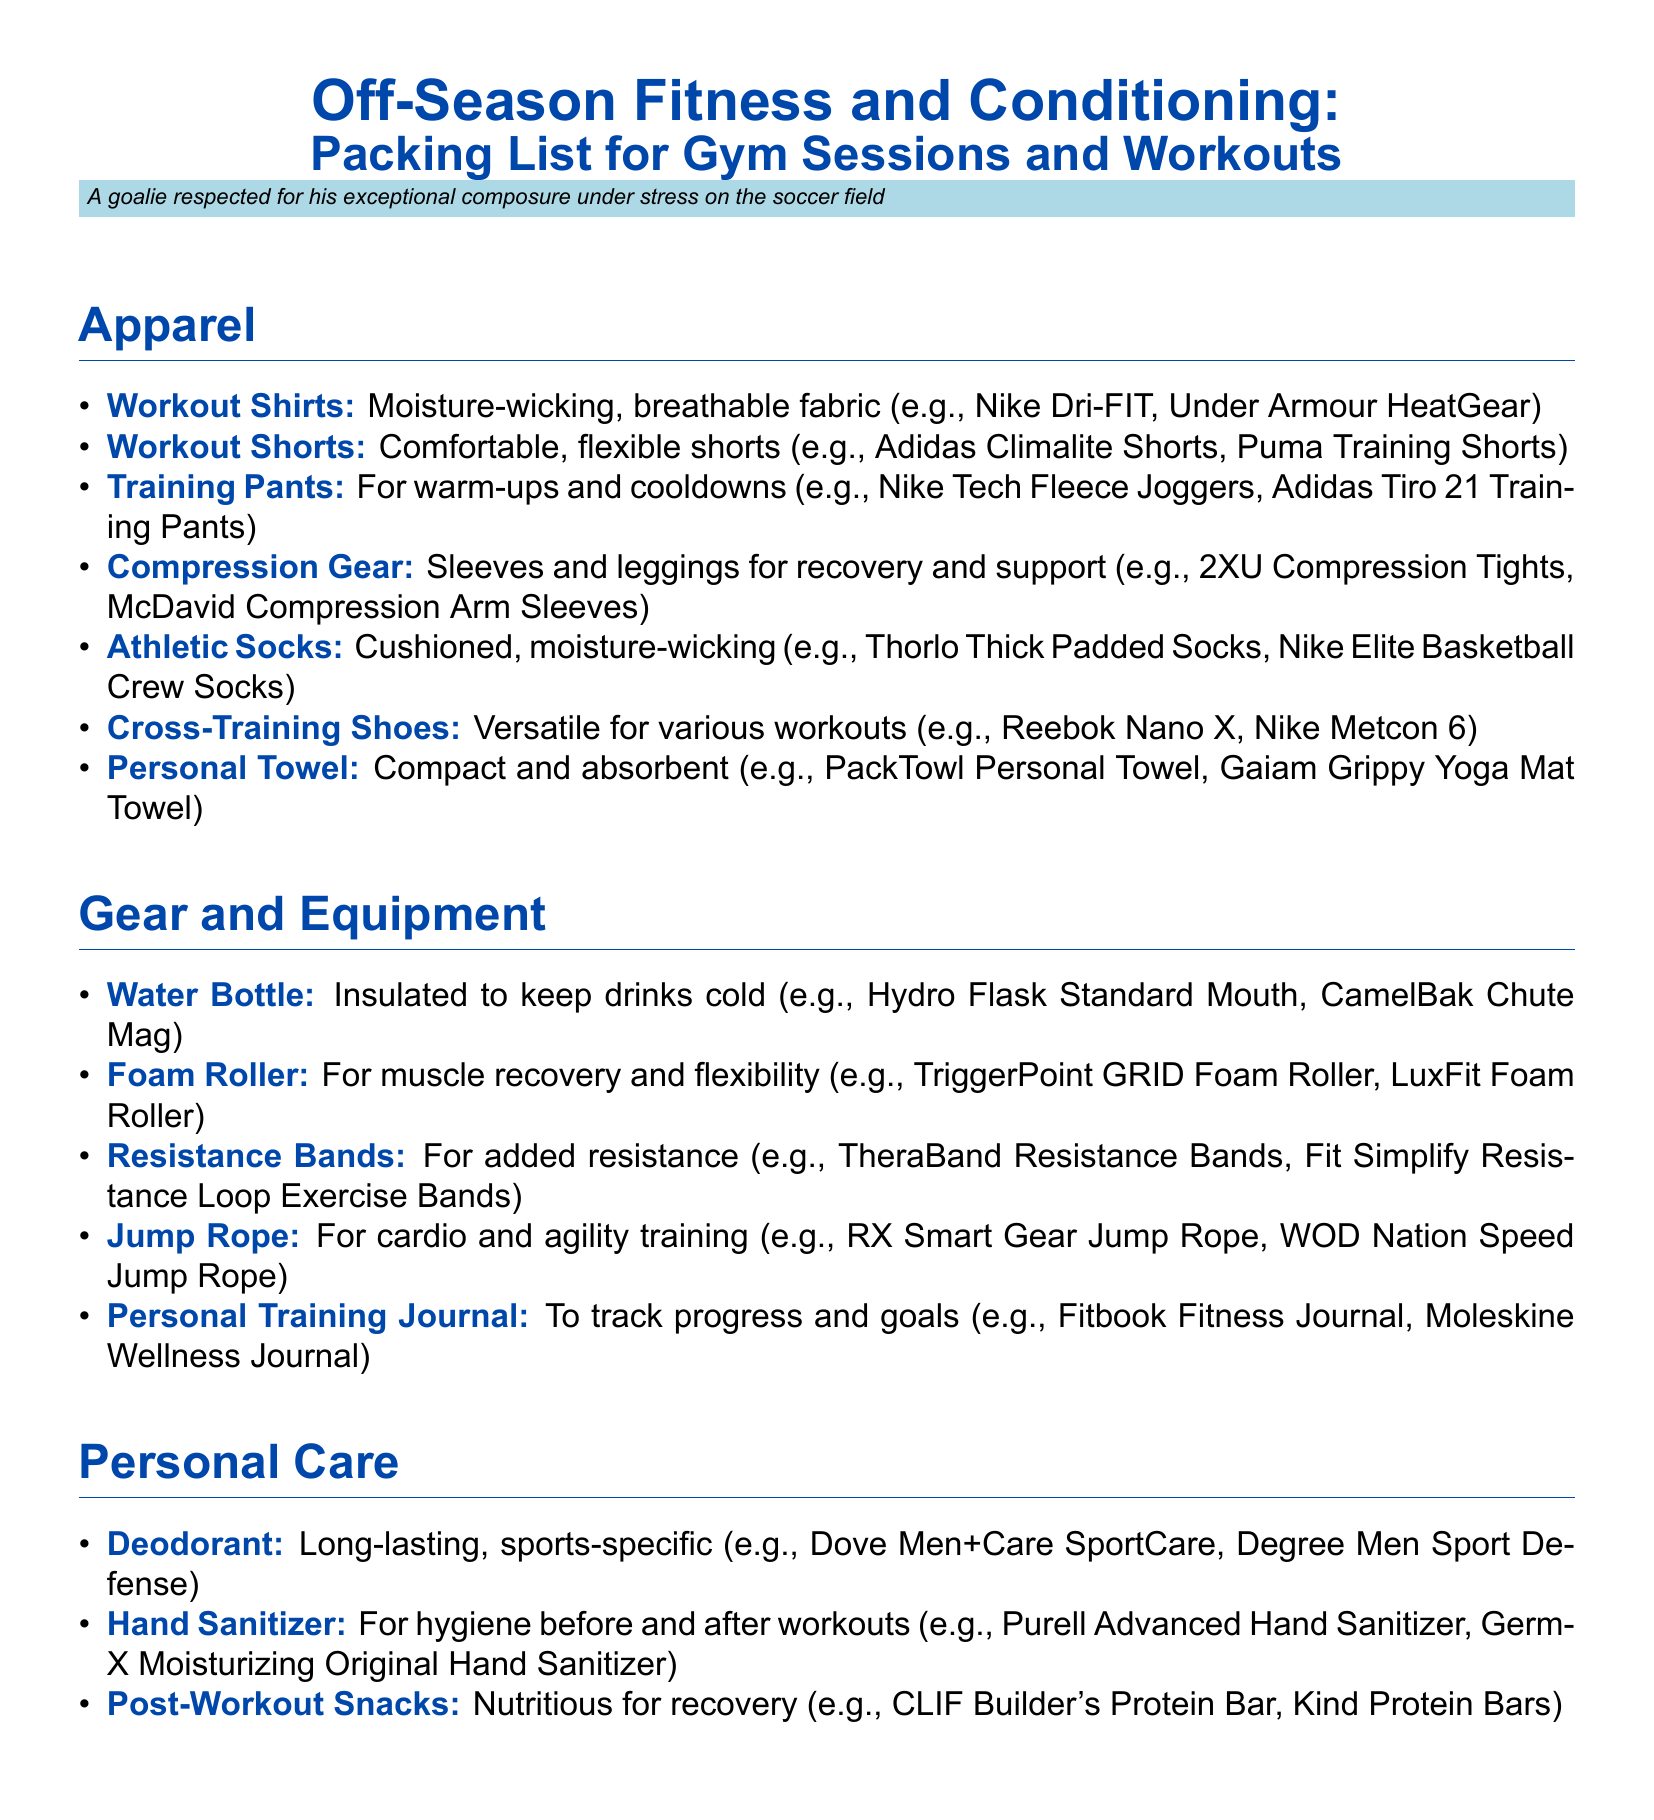What type of shirts are recommended? The document recommends moisture-wicking, breathable fabric shirts for workouts.
Answer: moisture-wicking, breathable fabric What should you bring for cardio training? The packing list suggests a jump rope for cardio and agility training.
Answer: jump rope How many types of socks are listed? The document lists one type of athletic sock, which are cushioned and moisture-wicking.
Answer: 1 What is required for warm-ups and cooldowns? Training pants are mentioned for warm-ups and cooldowns in the apparel section.
Answer: Training Pants What item is suggested for muscle recovery? The document includes a foam roller for muscle recovery and flexibility.
Answer: foam roller Which gear is insulated to keep drinks cold? The recommended water bottle is described as insulated to keep drinks cold.
Answer: Water Bottle What type of deodorant is suggested? The document suggests long-lasting, sports-specific deodorants.
Answer: sports-specific What is the purpose of the personal training journal? The personal training journal is for tracking progress and goals in workouts.
Answer: track progress and goals How many sections are in the packing list? There are three sections: Apparel, Gear and Equipment, Personal Care.
Answer: 3 